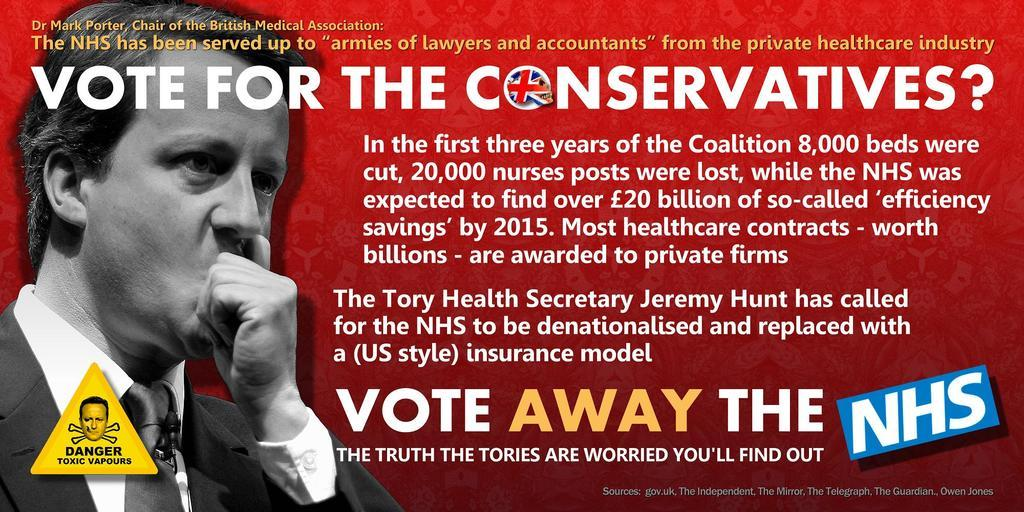What is the color scheme of the image? The image is black and white. Can you describe the person in the image? There is a man in the image. What type of clothing is the man wearing? The man is wearing a tie, a shirt, and a coat. What additional elements are present in the image? There is text and a logo on the image. What type of alarm can be heard in the image? There is no alarm present in the image; it is a black and white image featuring a man wearing a tie, shirt, and coat, with text and a logo. 